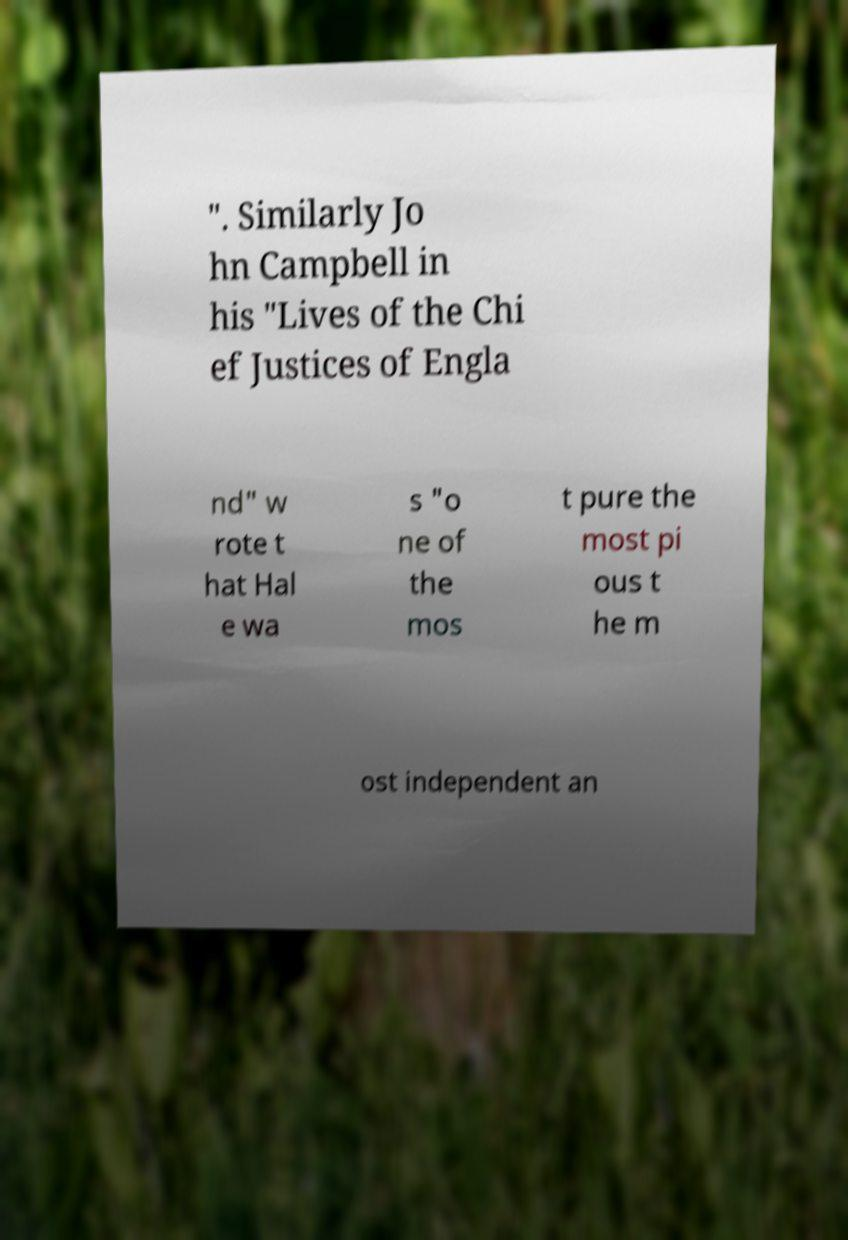There's text embedded in this image that I need extracted. Can you transcribe it verbatim? ". Similarly Jo hn Campbell in his "Lives of the Chi ef Justices of Engla nd" w rote t hat Hal e wa s "o ne of the mos t pure the most pi ous t he m ost independent an 